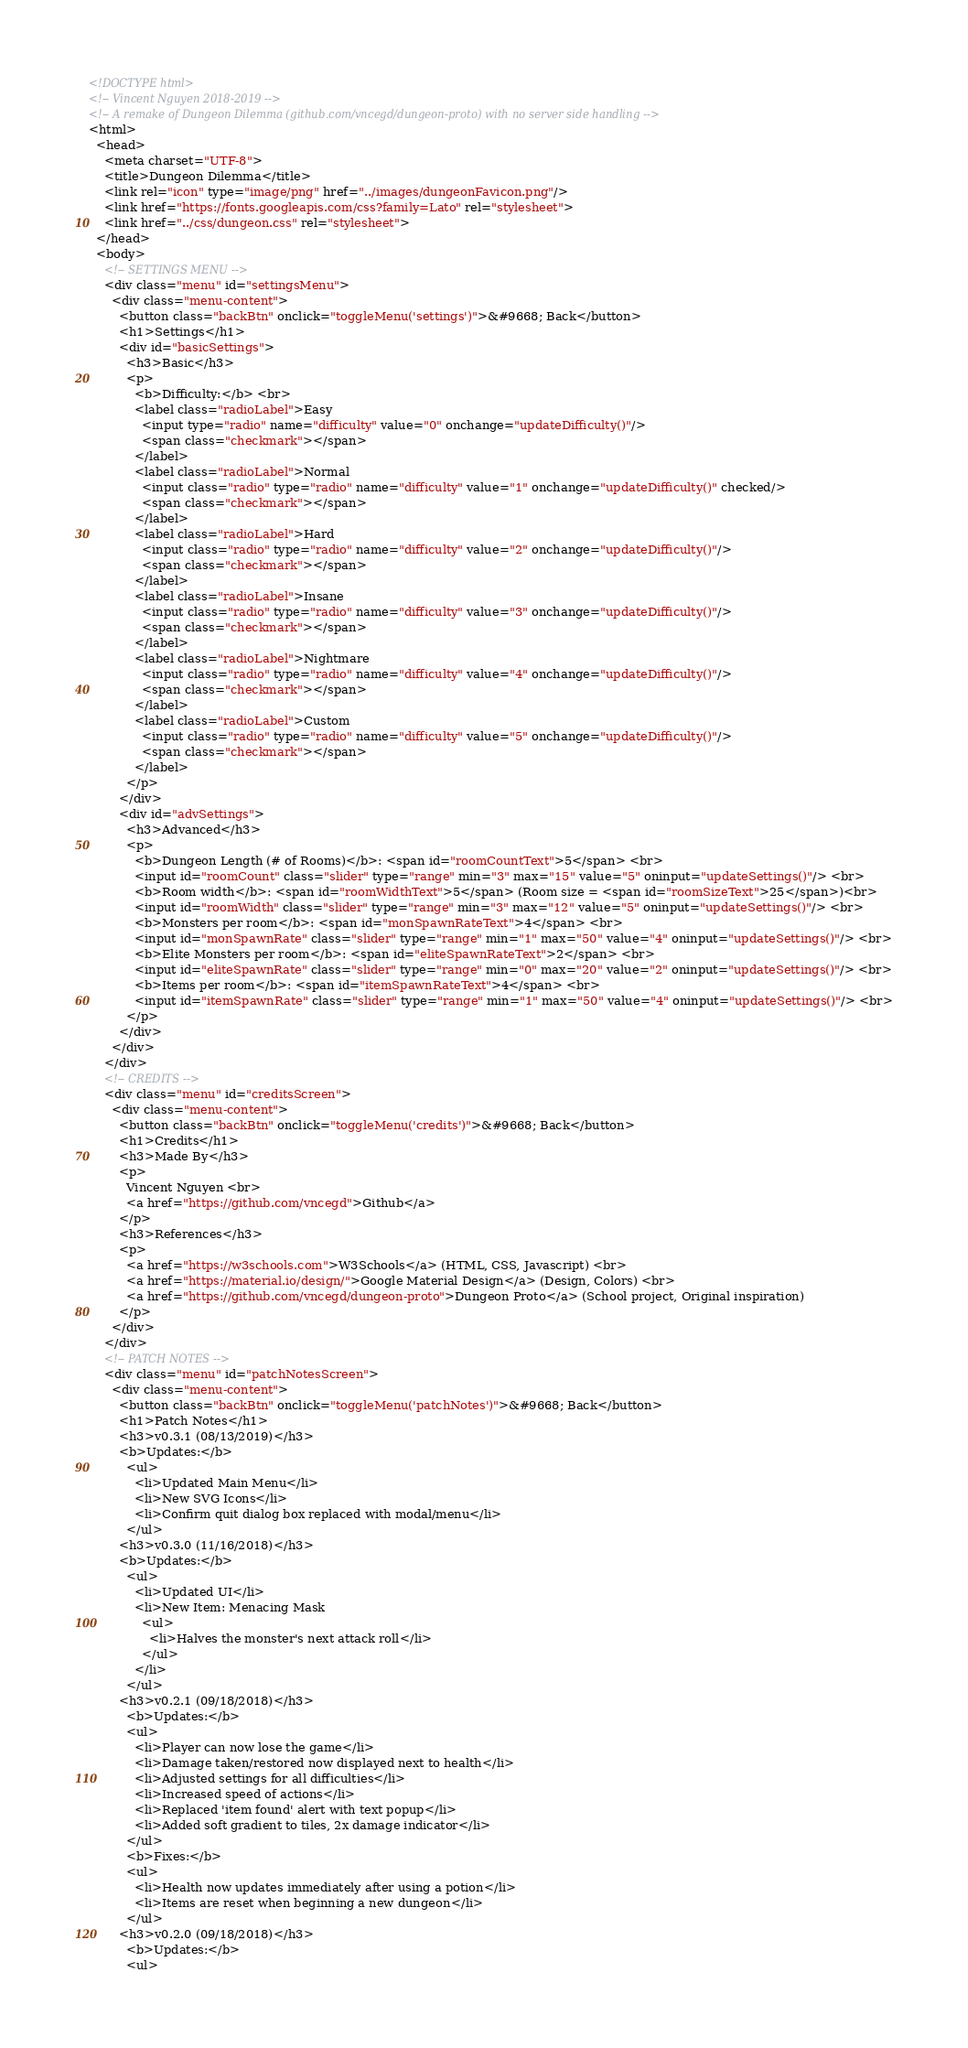<code> <loc_0><loc_0><loc_500><loc_500><_HTML_><!DOCTYPE html>
<!-- Vincent Nguyen 2018-2019 -->
<!-- A remake of Dungeon Dilemma (github.com/vncegd/dungeon-proto) with no server side handling -->
<html>
  <head>
    <meta charset="UTF-8">
    <title>Dungeon Dilemma</title>
    <link rel="icon" type="image/png" href="../images/dungeonFavicon.png"/>
    <link href="https://fonts.googleapis.com/css?family=Lato" rel="stylesheet">
    <link href="../css/dungeon.css" rel="stylesheet">
  </head>
  <body>
    <!-- SETTINGS MENU -->
    <div class="menu" id="settingsMenu">
      <div class="menu-content">
        <button class="backBtn" onclick="toggleMenu('settings')">&#9668; Back</button>
        <h1>Settings</h1>
        <div id="basicSettings">
          <h3>Basic</h3>
          <p>
            <b>Difficulty:</b> <br>
            <label class="radioLabel">Easy 
              <input type="radio" name="difficulty" value="0" onchange="updateDifficulty()"/>
              <span class="checkmark"></span>
            </label>
            <label class="radioLabel">Normal 
              <input class="radio" type="radio" name="difficulty" value="1" onchange="updateDifficulty()" checked/>
              <span class="checkmark"></span> 
            </label>
            <label class="radioLabel">Hard 
              <input class="radio" type="radio" name="difficulty" value="2" onchange="updateDifficulty()"/>
              <span class="checkmark"></span> 
            </label>
            <label class="radioLabel">Insane 
              <input class="radio" type="radio" name="difficulty" value="3" onchange="updateDifficulty()"/>
              <span class="checkmark"></span> 
            </label>
            <label class="radioLabel">Nightmare 
              <input class="radio" type="radio" name="difficulty" value="4" onchange="updateDifficulty()"/>
              <span class="checkmark"></span> 
            </label>
            <label class="radioLabel">Custom 
              <input class="radio" type="radio" name="difficulty" value="5" onchange="updateDifficulty()"/>
              <span class="checkmark"></span> 
            </label>
          </p>
        </div>
        <div id="advSettings">
          <h3>Advanced</h3>
          <p>
            <b>Dungeon Length (# of Rooms)</b>: <span id="roomCountText">5</span> <br>
            <input id="roomCount" class="slider" type="range" min="3" max="15" value="5" oninput="updateSettings()"/> <br>
            <b>Room width</b>: <span id="roomWidthText">5</span> (Room size = <span id="roomSizeText">25</span>)<br>
            <input id="roomWidth" class="slider" type="range" min="3" max="12" value="5" oninput="updateSettings()"/> <br>
            <b>Monsters per room</b>: <span id="monSpawnRateText">4</span> <br>
            <input id="monSpawnRate" class="slider" type="range" min="1" max="50" value="4" oninput="updateSettings()"/> <br>
            <b>Elite Monsters per room</b>: <span id="eliteSpawnRateText">2</span> <br>
            <input id="eliteSpawnRate" class="slider" type="range" min="0" max="20" value="2" oninput="updateSettings()"/> <br>
            <b>Items per room</b>: <span id="itemSpawnRateText">4</span> <br>
            <input id="itemSpawnRate" class="slider" type="range" min="1" max="50" value="4" oninput="updateSettings()"/> <br>
          </p>
        </div>
      </div>
    </div>
    <!-- CREDITS -->
    <div class="menu" id="creditsScreen">
      <div class="menu-content">
        <button class="backBtn" onclick="toggleMenu('credits')">&#9668; Back</button>
        <h1>Credits</h1>
        <h3>Made By</h3>
        <p>
          Vincent Nguyen <br>
          <a href="https://github.com/vncegd">Github</a>
        </p>
        <h3>References</h3>
        <p>
          <a href="https://w3schools.com">W3Schools</a> (HTML, CSS, Javascript) <br>
          <a href="https://material.io/design/">Google Material Design</a> (Design, Colors) <br>
          <a href="https://github.com/vncegd/dungeon-proto">Dungeon Proto</a> (School project, Original inspiration)
        </p>
      </div>
    </div>
    <!-- PATCH NOTES -->
    <div class="menu" id="patchNotesScreen">
      <div class="menu-content">
        <button class="backBtn" onclick="toggleMenu('patchNotes')">&#9668; Back</button>
        <h1>Patch Notes</h1>
        <h3>v0.3.1 (08/13/2019)</h3>
        <b>Updates:</b>
          <ul>
            <li>Updated Main Menu</li>
            <li>New SVG Icons</li>
            <li>Confirm quit dialog box replaced with modal/menu</li>
          </ul>
        <h3>v0.3.0 (11/16/2018)</h3>
        <b>Updates:</b>
          <ul>
            <li>Updated UI</li>
            <li>New Item: Menacing Mask
              <ul>
                <li>Halves the monster's next attack roll</li>
              </ul>
            </li>
          </ul>
        <h3>v0.2.1 (09/18/2018)</h3>
          <b>Updates:</b>
          <ul>
            <li>Player can now lose the game</li>
            <li>Damage taken/restored now displayed next to health</li> 
            <li>Adjusted settings for all difficulties</li>
            <li>Increased speed of actions</li>
            <li>Replaced 'item found' alert with text popup</li>
            <li>Added soft gradient to tiles, 2x damage indicator</li>
          </ul>
          <b>Fixes:</b>
          <ul>
            <li>Health now updates immediately after using a potion</li>
            <li>Items are reset when beginning a new dungeon</li>
          </ul>
        <h3>v0.2.0 (09/18/2018)</h3>
          <b>Updates:</b>
          <ul></code> 